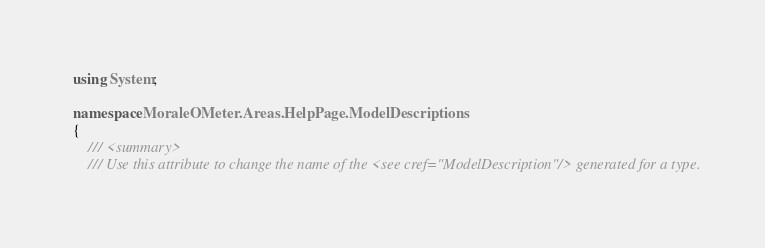Convert code to text. <code><loc_0><loc_0><loc_500><loc_500><_C#_>using System;

namespace MoraleOMeter.Areas.HelpPage.ModelDescriptions
{
    /// <summary>
    /// Use this attribute to change the name of the <see cref="ModelDescription"/> generated for a type.</code> 